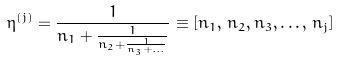Convert formula to latex. <formula><loc_0><loc_0><loc_500><loc_500>\eta ^ { ( j ) } = \frac { 1 } { n _ { 1 } + \frac { 1 } { n _ { 2 } + \frac { 1 } { n _ { 3 } + \dots } } } \equiv [ n _ { 1 } , \, n _ { 2 } , n _ { 3 } , \dots , \, n _ { j } ]</formula> 